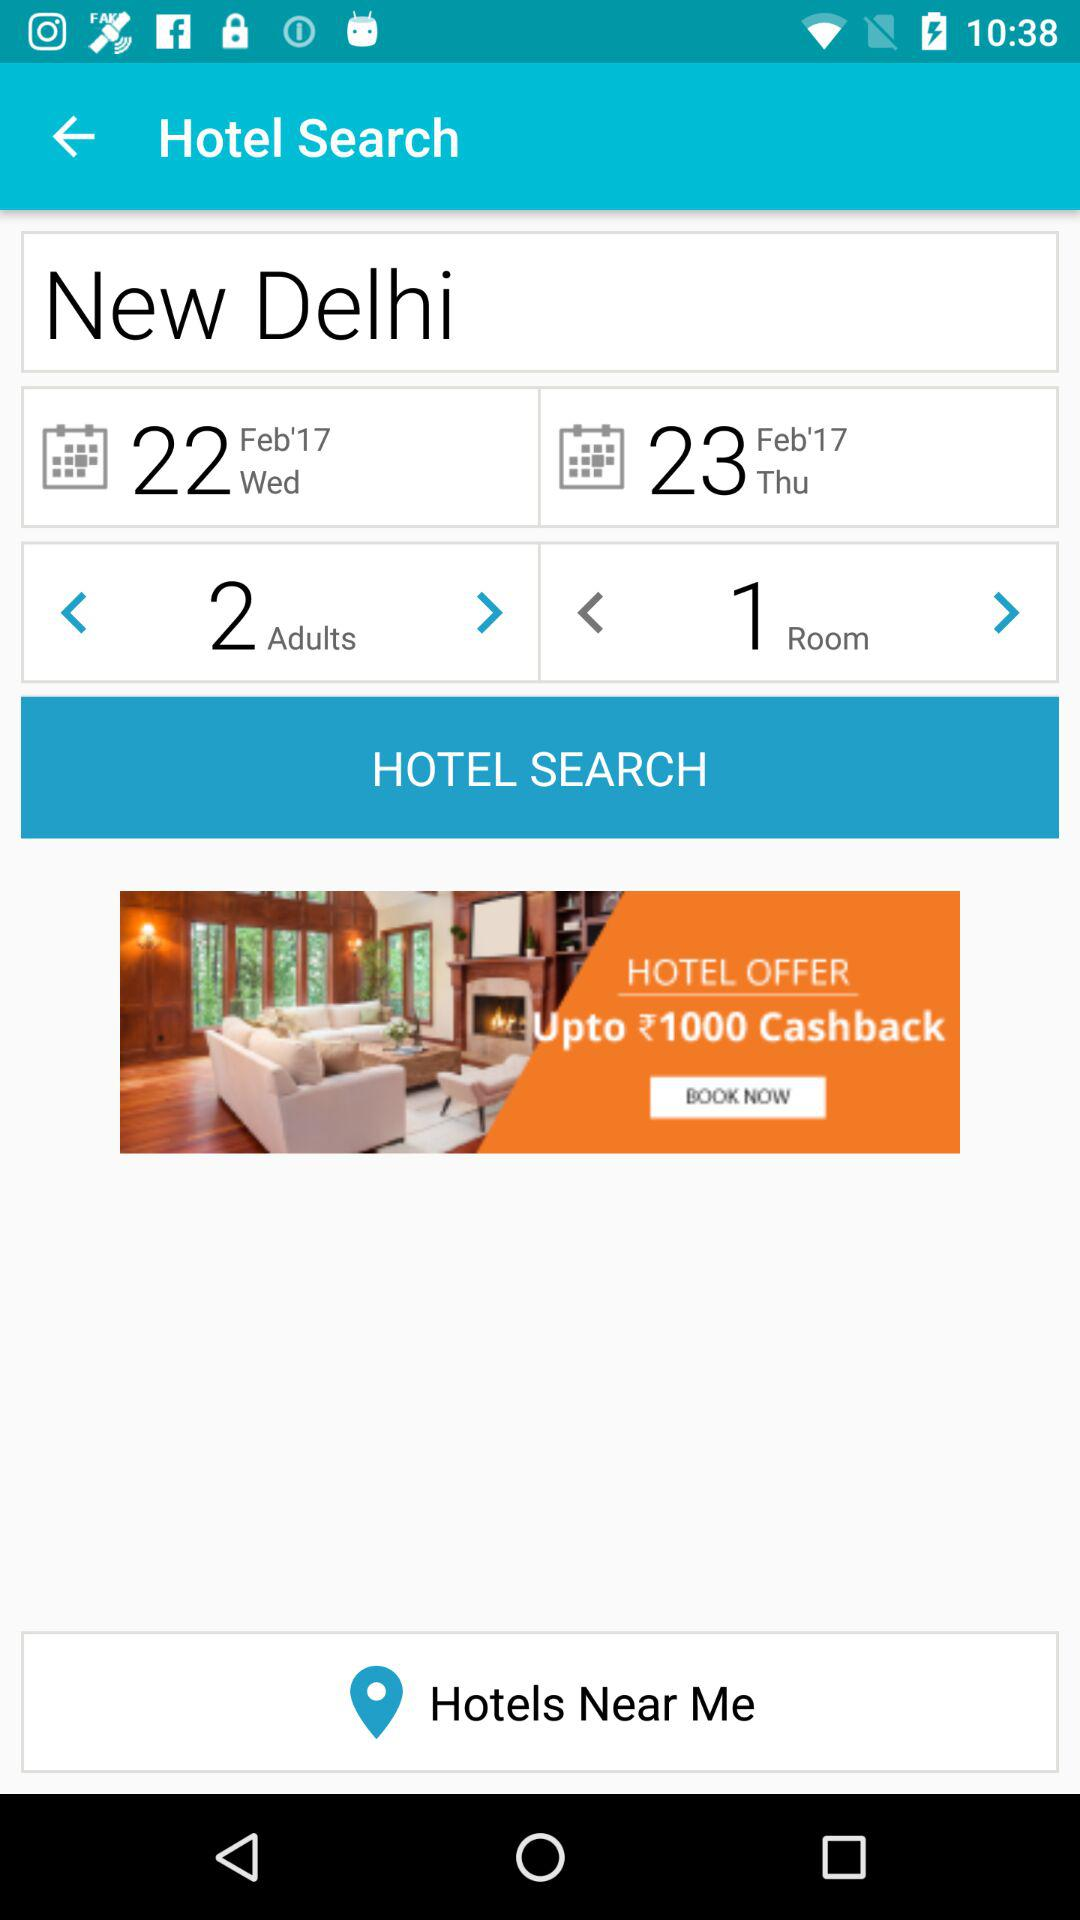How many more days are in the second date than the first date?
Answer the question using a single word or phrase. 1 